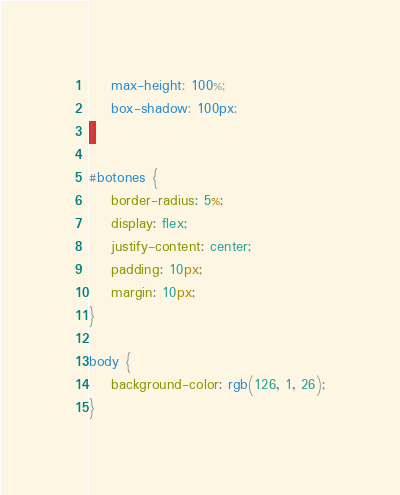<code> <loc_0><loc_0><loc_500><loc_500><_CSS_>    max-height: 100%;
    box-shadow: 100px;
}

#botones {
    border-radius: 5%;
    display: flex;
    justify-content: center;
    padding: 10px;
    margin: 10px;
}

body {
    background-color: rgb(126, 1, 26);
}</code> 